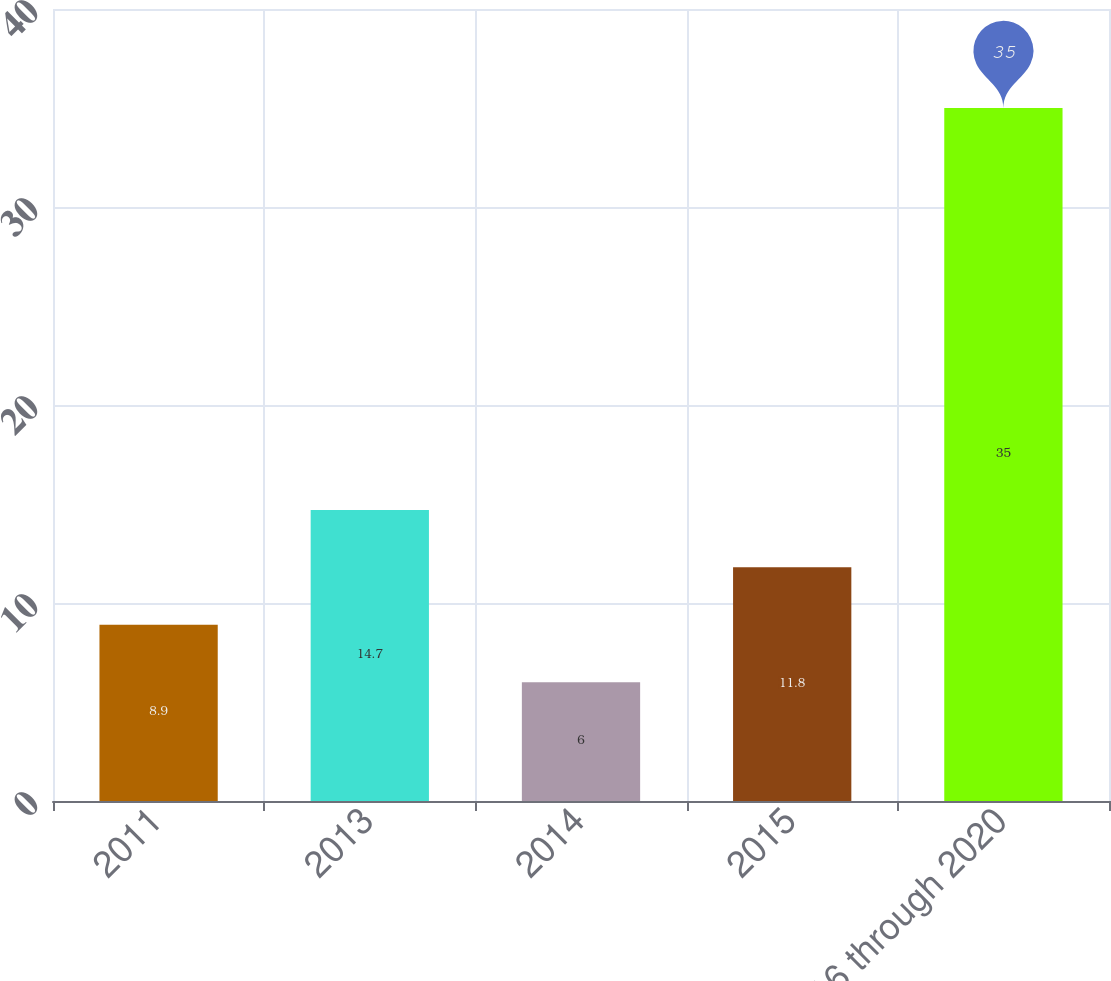<chart> <loc_0><loc_0><loc_500><loc_500><bar_chart><fcel>2011<fcel>2013<fcel>2014<fcel>2015<fcel>2016 through 2020<nl><fcel>8.9<fcel>14.7<fcel>6<fcel>11.8<fcel>35<nl></chart> 